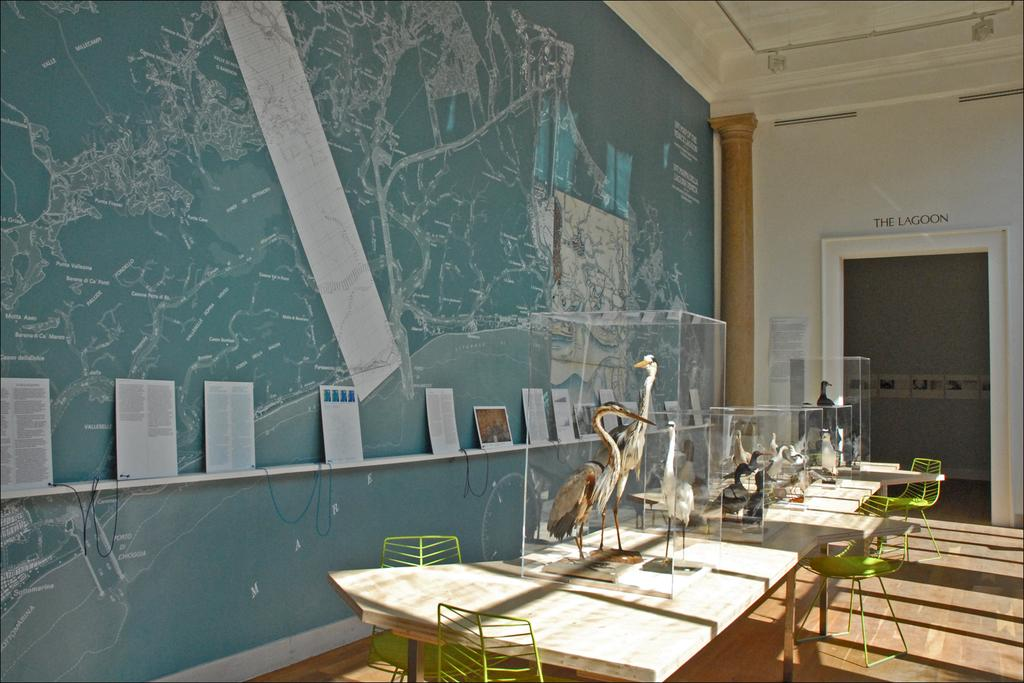What type of furniture is present in the image? There are chairs and tables in the image. What is unique about the birds in the image? The birds are in glasses in the image. What can be seen on the left side of the image? There is a wall on the left side of the image. What type of cap is the fowl wearing in the image? There are no fowls or caps present in the image. The birds in the image are in glasses, not wearing caps. 